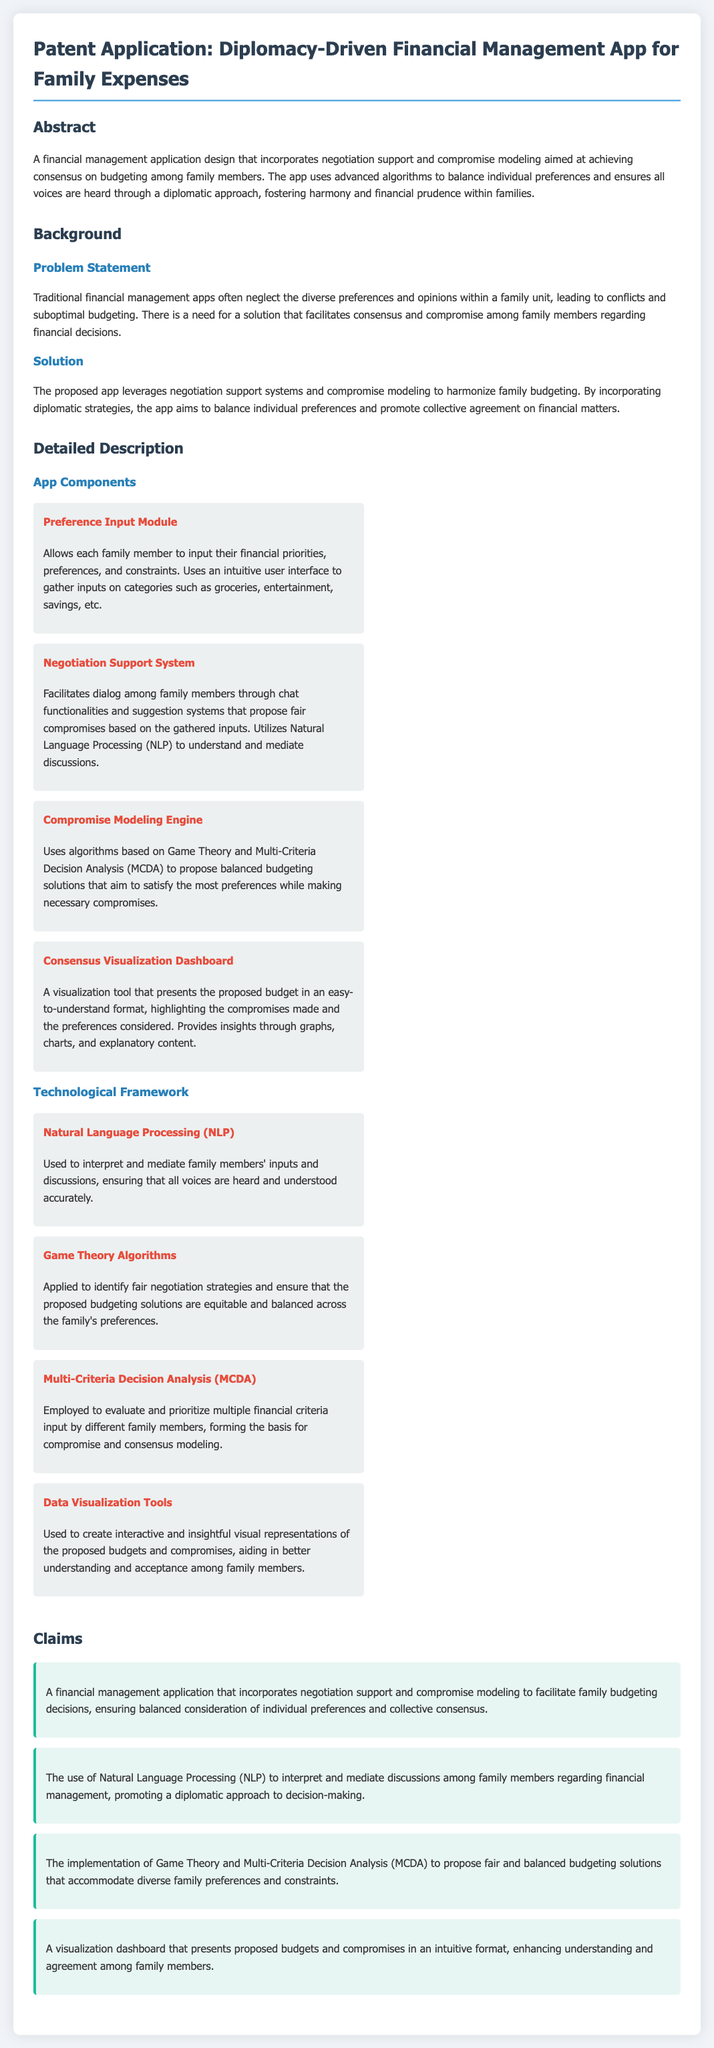What is the title of the patent application? The title of the patent application is stated in the heading of the document.
Answer: Diplomacy-Driven Financial Management App for Family Expenses How many modules are described in the app components? The app sections describe four specific components, each indicated clearly.
Answer: Four What technology is used to interpret family discussions? The specific technology responsible for interpreting discussions among family members is mentioned in the technological framework section.
Answer: Natural Language Processing (NLP) What is the main problem addressed by the app? The main problem is articulated under the problem statement in the background section.
Answer: Conflicts and suboptimal budgeting What approach does the app utilize to propose solutions? The approach employed to harmonize family budgeting is outlined in the solution segment of the document.
Answer: Negotiation support systems and compromise modeling What type of visualization tool does the app provide? The type of visualization tool offered by the app is described in the app component section.
Answer: Consensus Visualization Dashboard What algorithms are applied for negotiation strategies? The algorithms used to ensure fair negotiation strategies are specified in the technology section.
Answer: Game Theory Algorithms How does the app aid in understanding among family members? The method by which the app enhances understanding is described in the claims section regarding visualization tools.
Answer: Intuitive format Which analysis method is used for prioritizing financial criteria? The analytical method mentioned for prioritizing financial criteria is highlighted in the technological framework.
Answer: Multi-Criteria Decision Analysis (MCDA) 